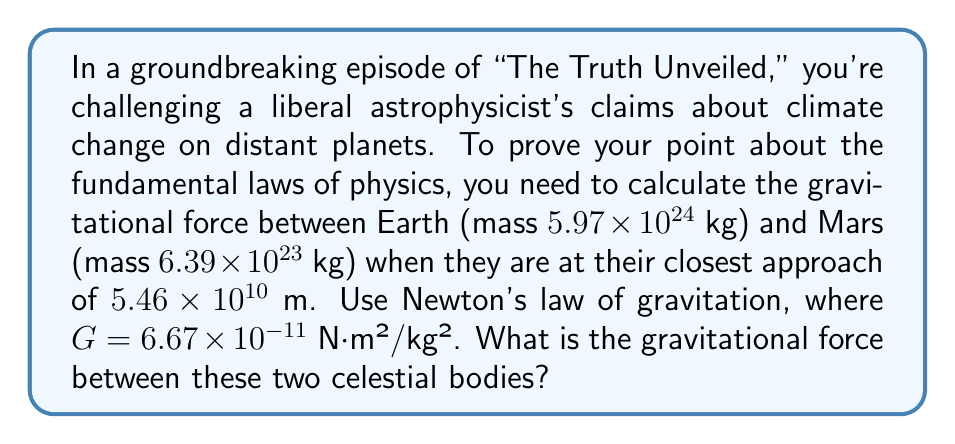Provide a solution to this math problem. Let's approach this step-by-step using Newton's law of gravitation:

1) Newton's law of gravitation states that the force (F) between two masses (m₁ and m₂) is:

   $$F = G \frac{m_1 m_2}{r^2}$$

   where G is the gravitational constant and r is the distance between the centers of the masses.

2) We have:
   - G = $6.67 \times 10^{-11}$ N⋅m²/kg²
   - m₁ (Earth's mass) = $5.97 \times 10^{24}$ kg
   - m₂ (Mars' mass) = $6.39 \times 10^{23}$ kg
   - r (distance) = $5.46 \times 10^{10}$ m

3) Let's substitute these values into the equation:

   $$F = (6.67 \times 10^{-11}) \frac{(5.97 \times 10^{24})(6.39 \times 10^{23})}{(5.46 \times 10^{10})^2}$$

4) Simplify the numerator:
   $$(6.67 \times 10^{-11})(5.97 \times 10^{24})(6.39 \times 10^{23}) = 2.55 \times 10^{38}$$

5) Simplify the denominator:
   $$(5.46 \times 10^{10})^2 = 2.98 \times 10^{21}$$

6) Divide:
   $$F = \frac{2.55 \times 10^{38}}{2.98 \times 10^{21}} = 8.56 \times 10^{16}$$

Therefore, the gravitational force between Earth and Mars at their closest approach is approximately $8.56 \times 10^{16}$ N.
Answer: $8.56 \times 10^{16}$ N 